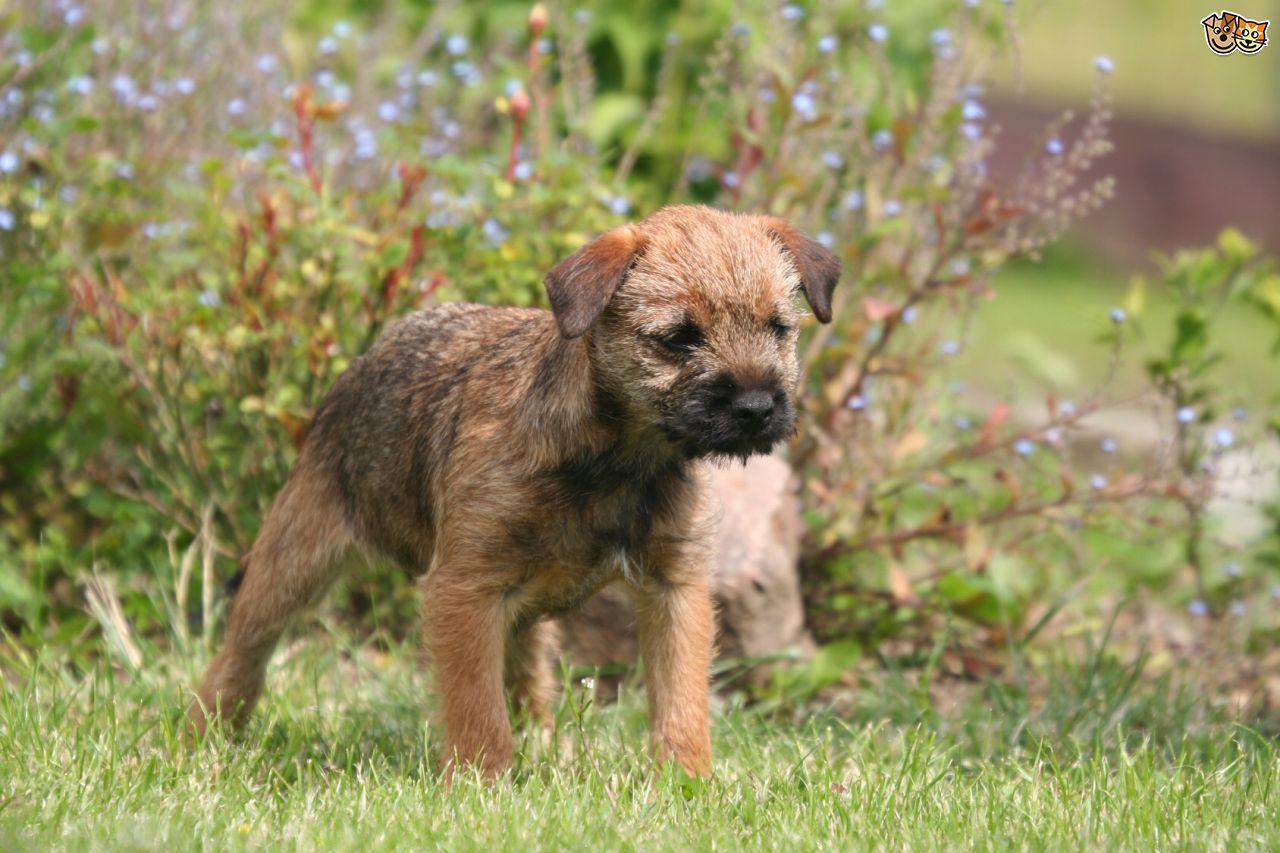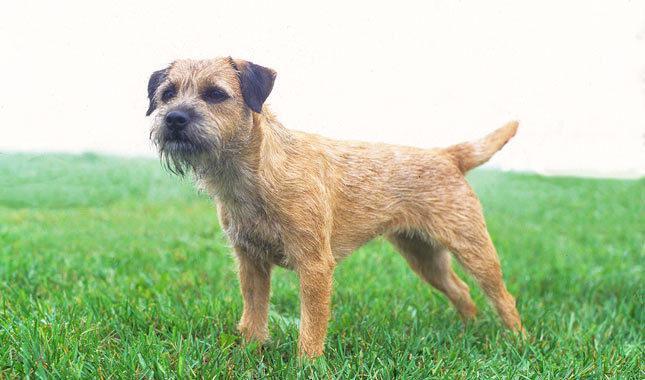The first image is the image on the left, the second image is the image on the right. For the images displayed, is the sentence "The right image has exactly one dog who's body is facing towards the left." factually correct? Answer yes or no. Yes. The first image is the image on the left, the second image is the image on the right. Analyze the images presented: Is the assertion "Both dogs are facing the same direction." valid? Answer yes or no. No. 